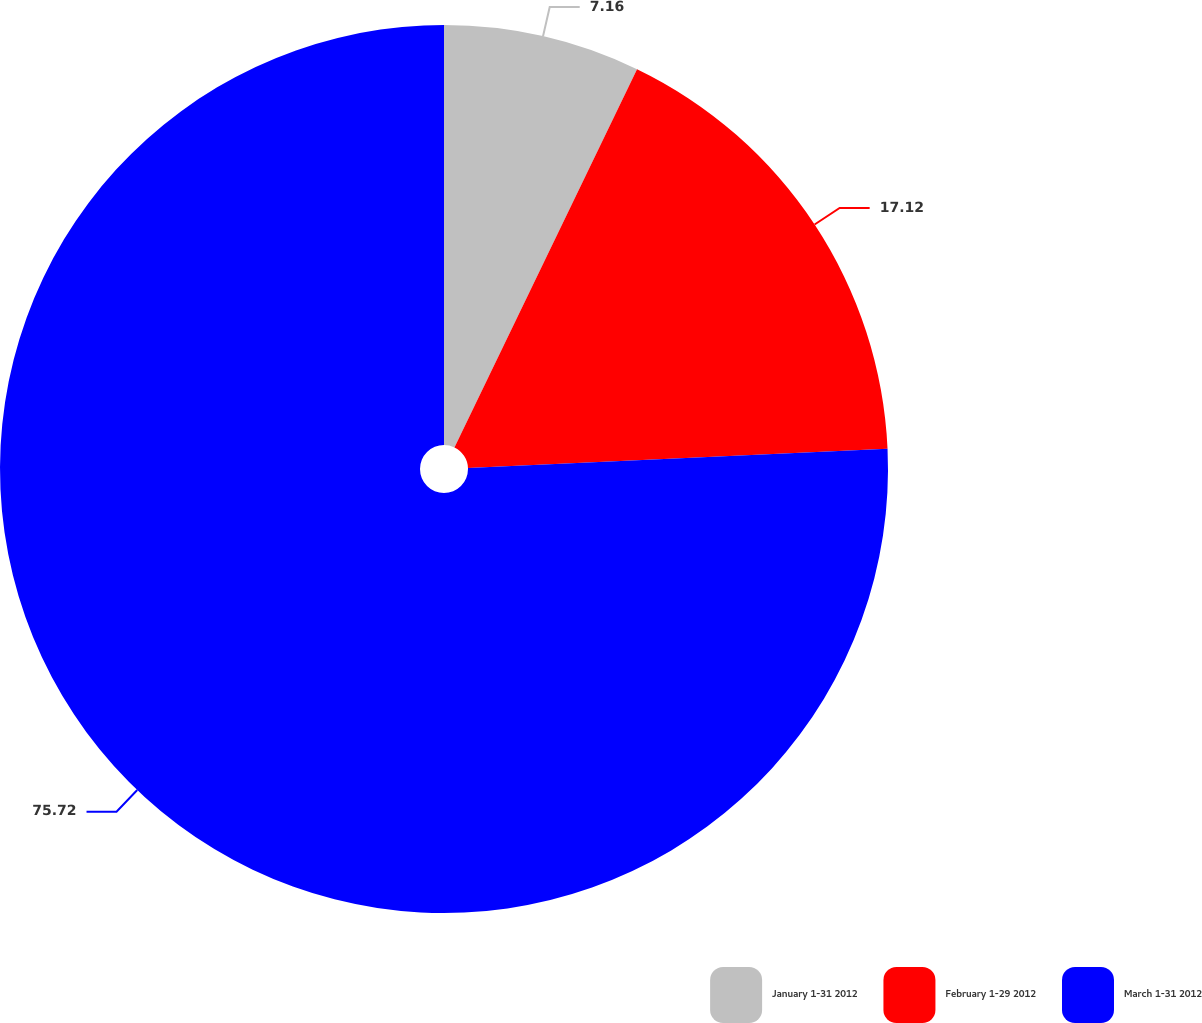Convert chart to OTSL. <chart><loc_0><loc_0><loc_500><loc_500><pie_chart><fcel>January 1-31 2012<fcel>February 1-29 2012<fcel>March 1-31 2012<nl><fcel>7.16%<fcel>17.12%<fcel>75.73%<nl></chart> 